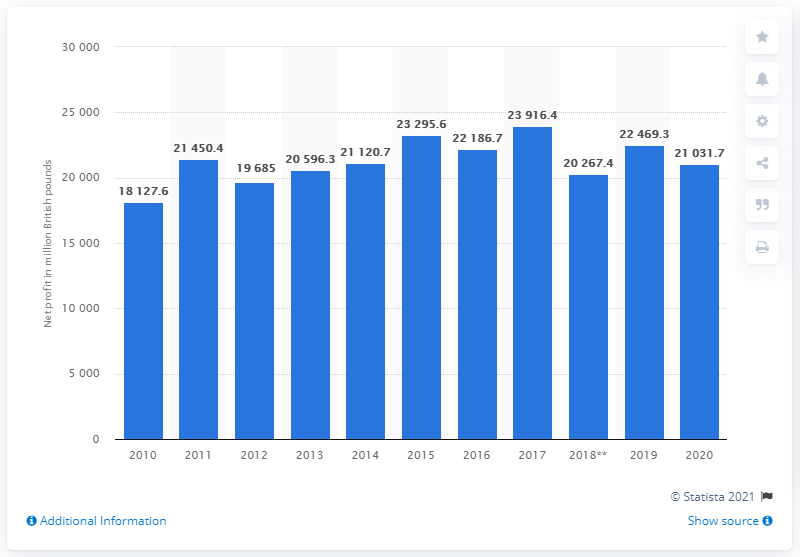Indicate a few pertinent items in this graphic. In the 2020 fiscal year, SSE plc's total assets were valued at 21,031.7. 